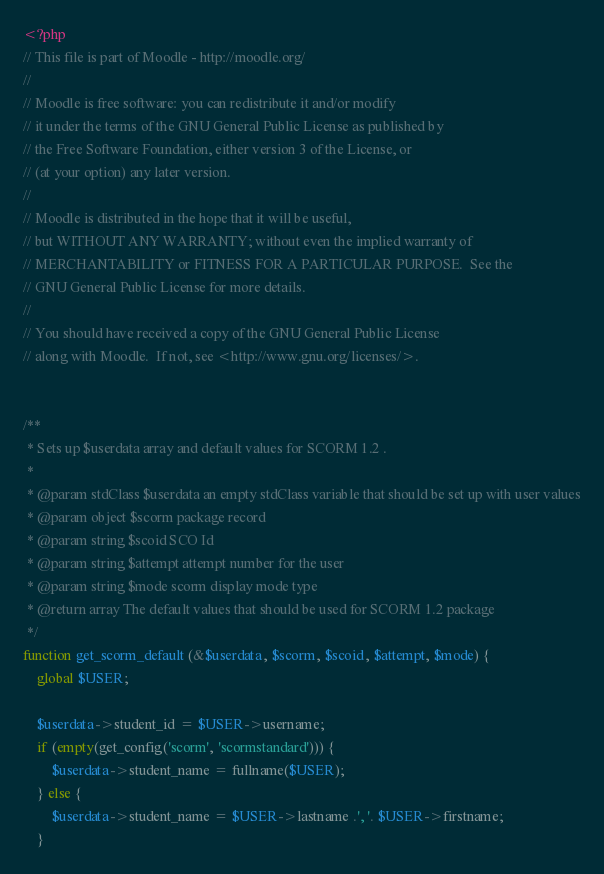Convert code to text. <code><loc_0><loc_0><loc_500><loc_500><_PHP_><?php
// This file is part of Moodle - http://moodle.org/
//
// Moodle is free software: you can redistribute it and/or modify
// it under the terms of the GNU General Public License as published by
// the Free Software Foundation, either version 3 of the License, or
// (at your option) any later version.
//
// Moodle is distributed in the hope that it will be useful,
// but WITHOUT ANY WARRANTY; without even the implied warranty of
// MERCHANTABILITY or FITNESS FOR A PARTICULAR PURPOSE.  See the
// GNU General Public License for more details.
//
// You should have received a copy of the GNU General Public License
// along with Moodle.  If not, see <http://www.gnu.org/licenses/>.


/**
 * Sets up $userdata array and default values for SCORM 1.2 .
 *
 * @param stdClass $userdata an empty stdClass variable that should be set up with user values
 * @param object $scorm package record
 * @param string $scoid SCO Id
 * @param string $attempt attempt number for the user
 * @param string $mode scorm display mode type
 * @return array The default values that should be used for SCORM 1.2 package
 */
function get_scorm_default (&$userdata, $scorm, $scoid, $attempt, $mode) {
    global $USER;

    $userdata->student_id = $USER->username;
    if (empty(get_config('scorm', 'scormstandard'))) {
        $userdata->student_name = fullname($USER);
    } else {
        $userdata->student_name = $USER->lastname .', '. $USER->firstname;
    }
</code> 